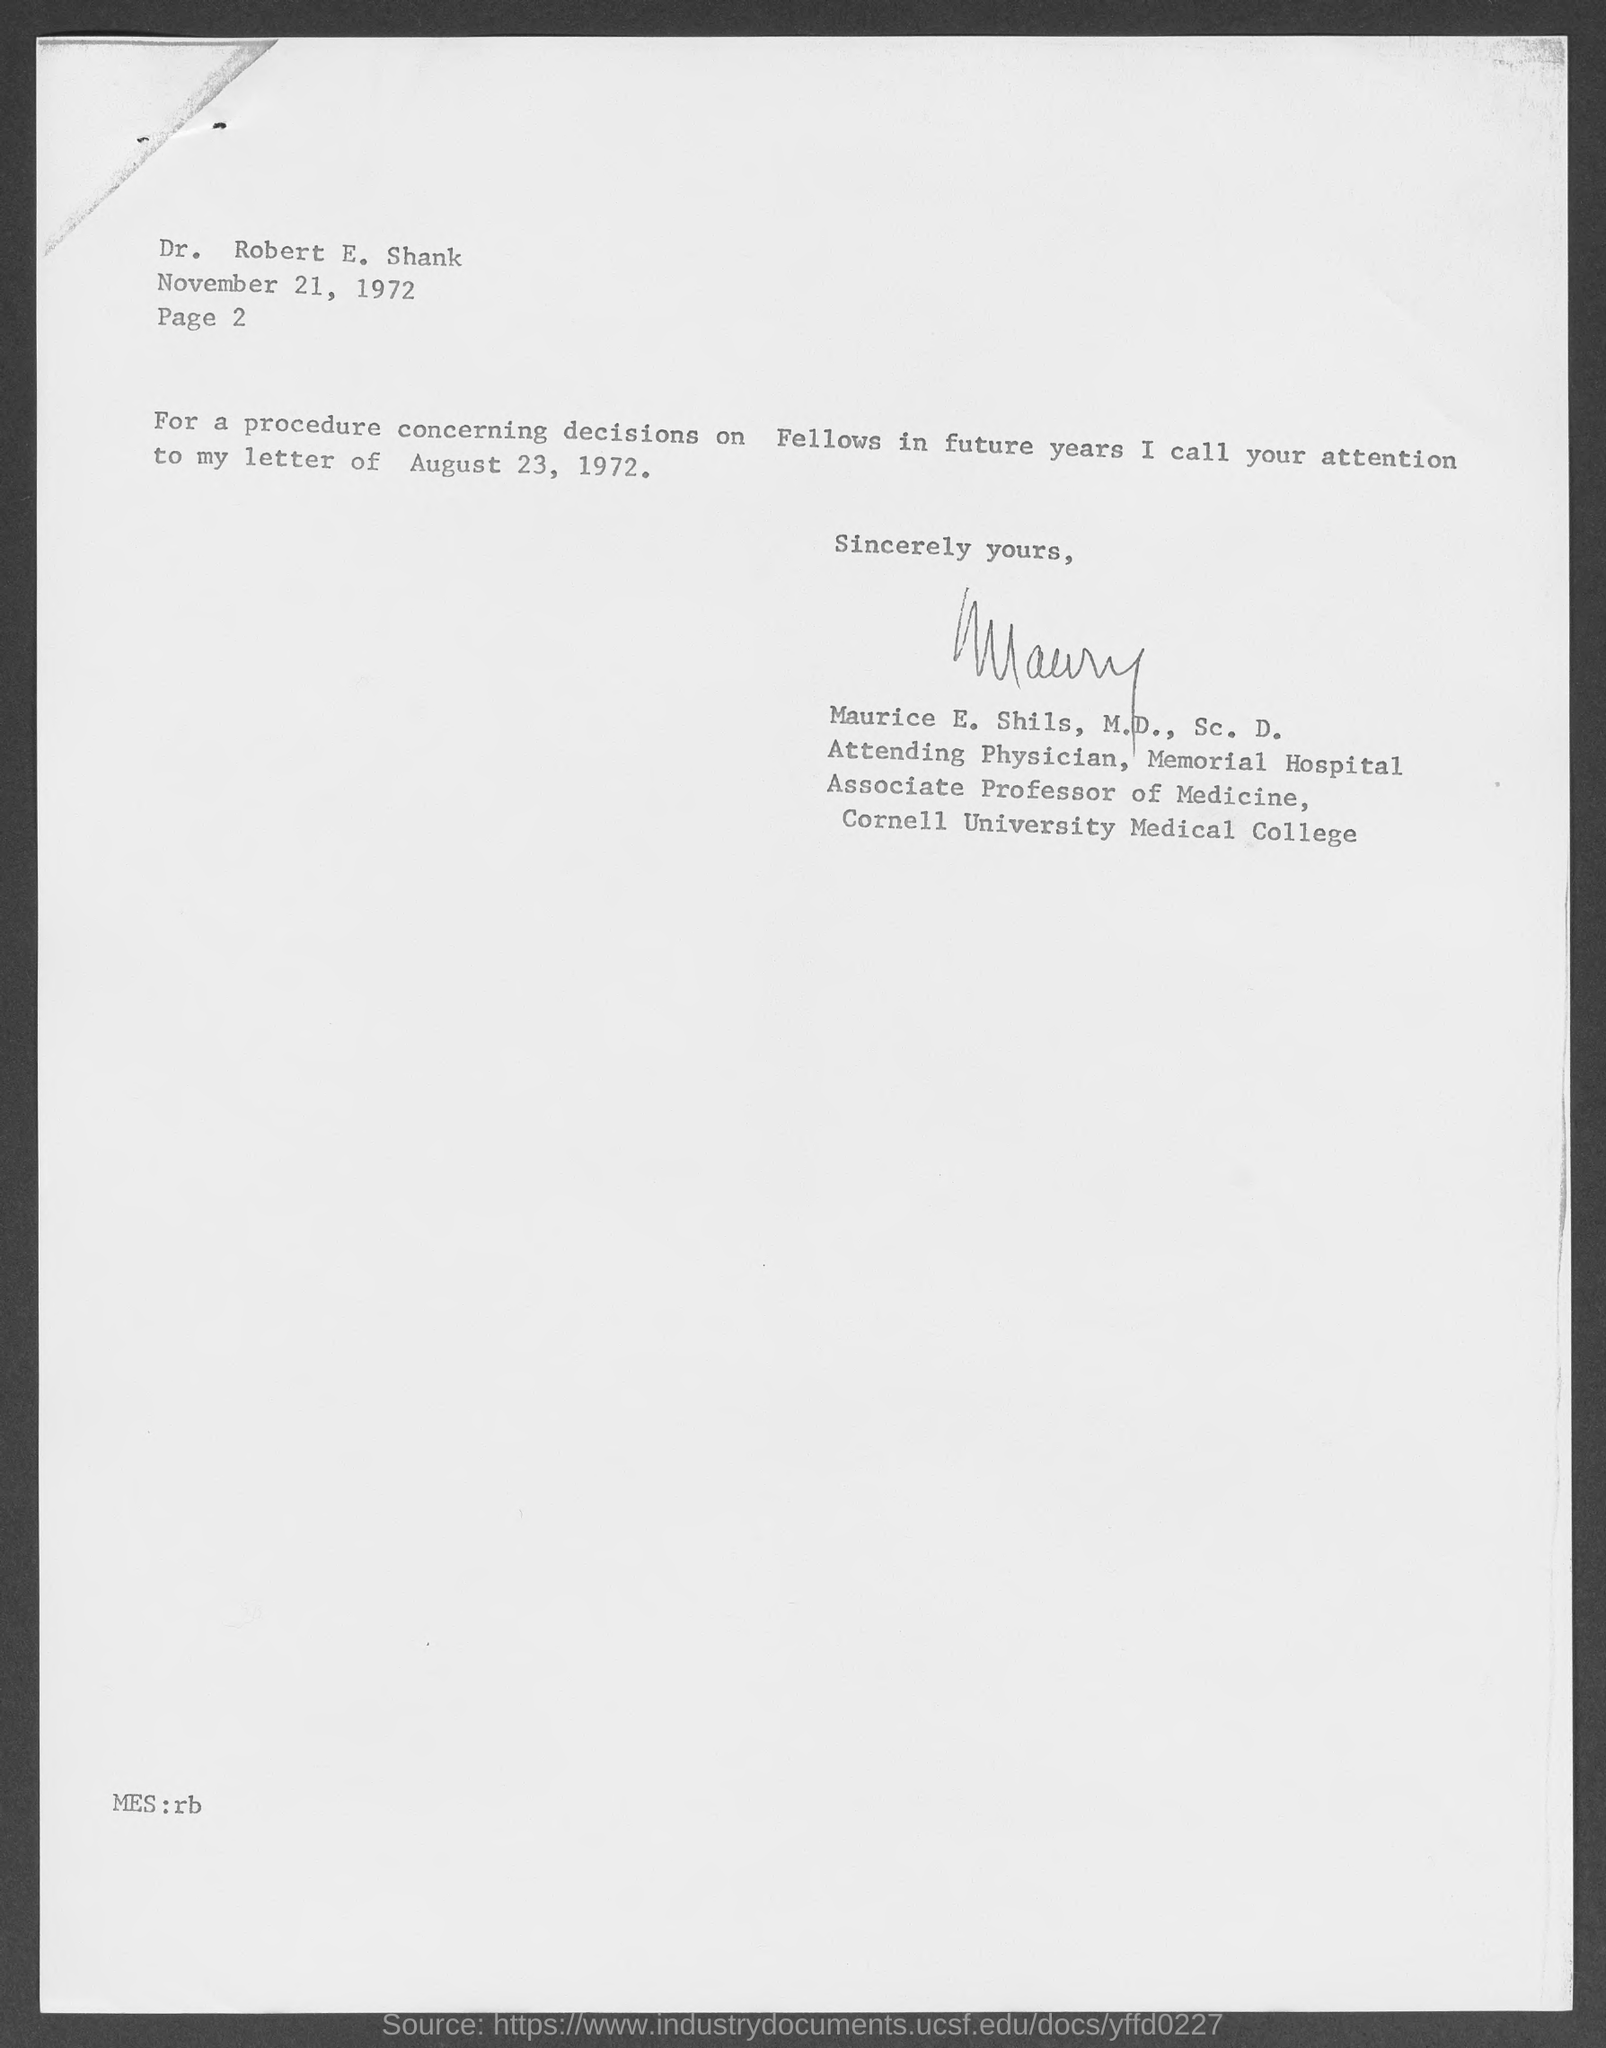Give some essential details in this illustration. The letter is addressed to Robert E. Shank. 